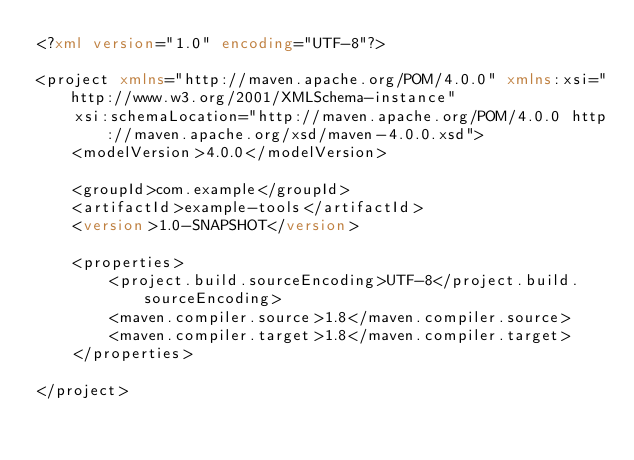Convert code to text. <code><loc_0><loc_0><loc_500><loc_500><_XML_><?xml version="1.0" encoding="UTF-8"?>

<project xmlns="http://maven.apache.org/POM/4.0.0" xmlns:xsi="http://www.w3.org/2001/XMLSchema-instance"
    xsi:schemaLocation="http://maven.apache.org/POM/4.0.0 http://maven.apache.org/xsd/maven-4.0.0.xsd">
    <modelVersion>4.0.0</modelVersion>

    <groupId>com.example</groupId>
    <artifactId>example-tools</artifactId>
    <version>1.0-SNAPSHOT</version>

    <properties>
        <project.build.sourceEncoding>UTF-8</project.build.sourceEncoding>
        <maven.compiler.source>1.8</maven.compiler.source>
        <maven.compiler.target>1.8</maven.compiler.target>
    </properties>

</project>
</code> 